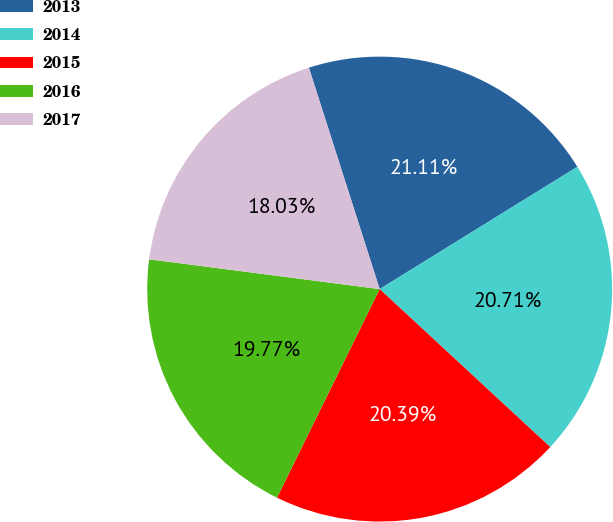Convert chart to OTSL. <chart><loc_0><loc_0><loc_500><loc_500><pie_chart><fcel>2013<fcel>2014<fcel>2015<fcel>2016<fcel>2017<nl><fcel>21.11%<fcel>20.71%<fcel>20.39%<fcel>19.77%<fcel>18.03%<nl></chart> 